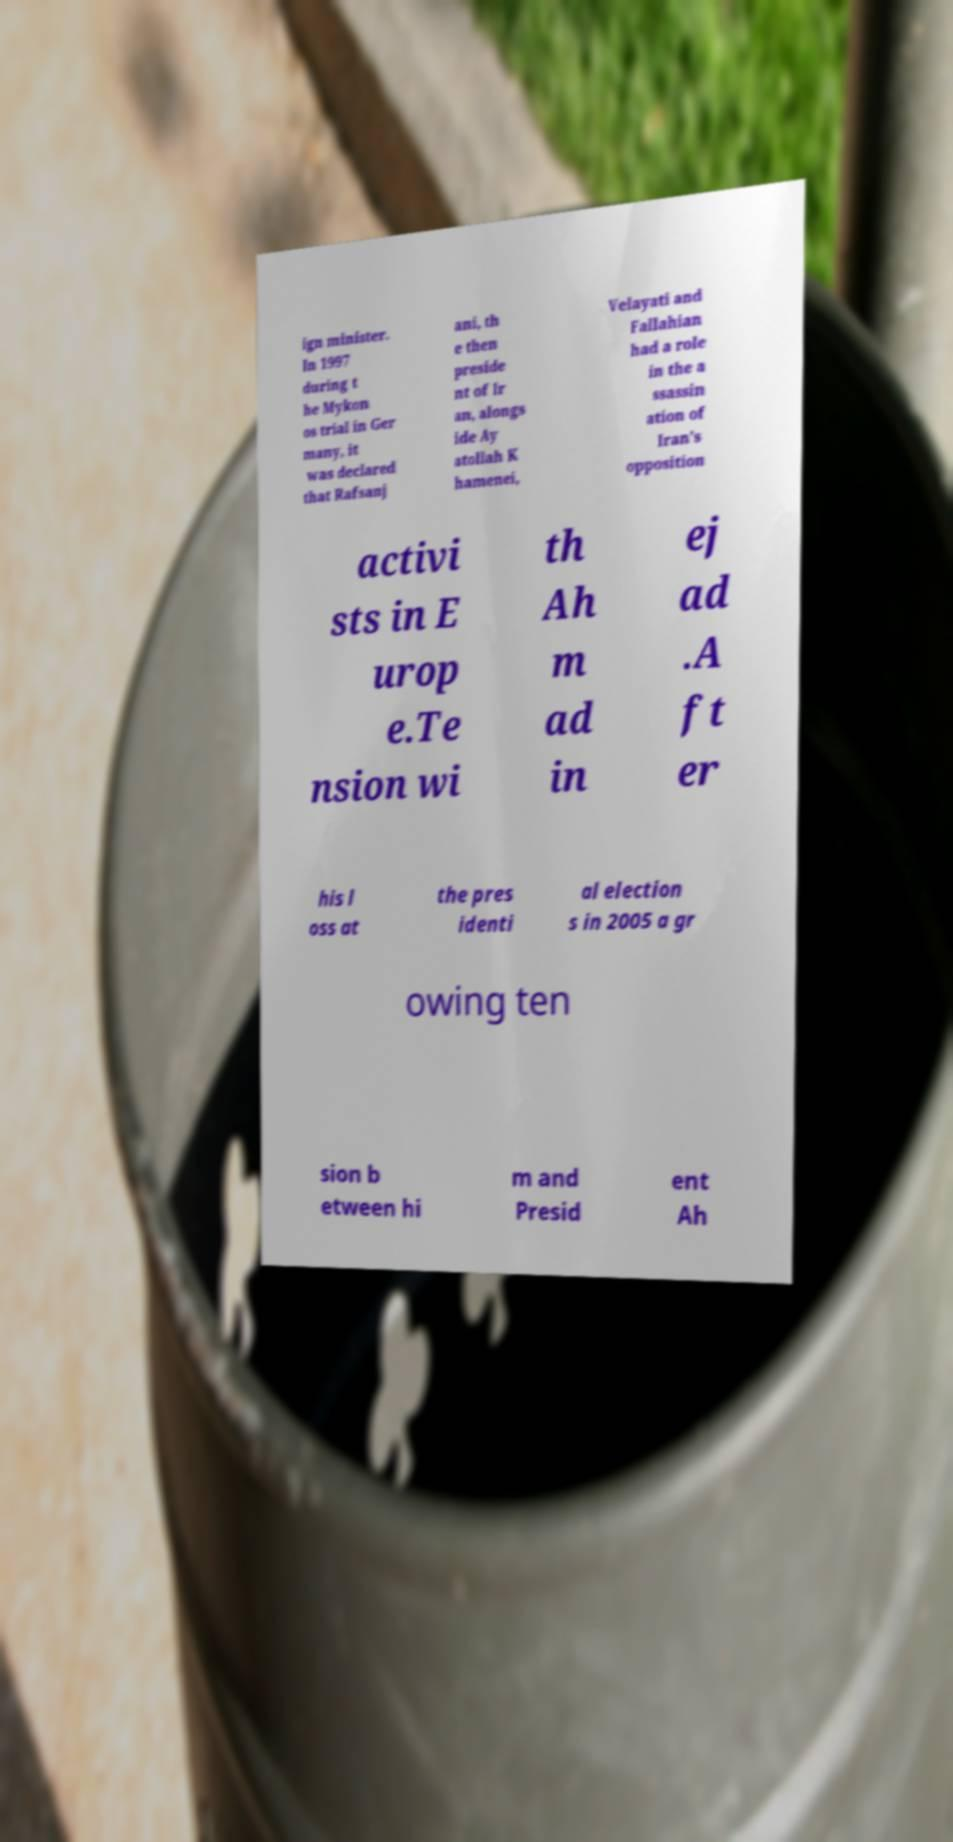Please read and relay the text visible in this image. What does it say? ign minister. In 1997 during t he Mykon os trial in Ger many, it was declared that Rafsanj ani, th e then preside nt of Ir an, alongs ide Ay atollah K hamenei, Velayati and Fallahian had a role in the a ssassin ation of Iran's opposition activi sts in E urop e.Te nsion wi th Ah m ad in ej ad .A ft er his l oss at the pres identi al election s in 2005 a gr owing ten sion b etween hi m and Presid ent Ah 